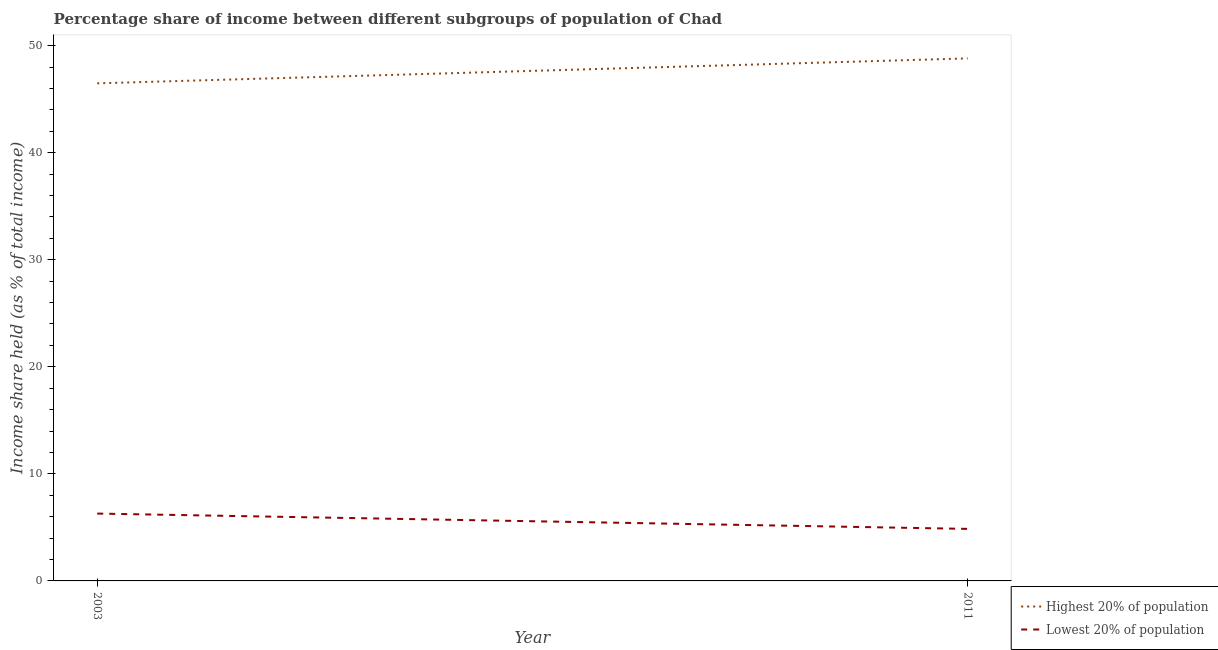What is the income share held by highest 20% of the population in 2003?
Provide a short and direct response. 46.48. Across all years, what is the maximum income share held by lowest 20% of the population?
Offer a very short reply. 6.29. Across all years, what is the minimum income share held by highest 20% of the population?
Your answer should be very brief. 46.48. In which year was the income share held by highest 20% of the population maximum?
Your response must be concise. 2011. In which year was the income share held by highest 20% of the population minimum?
Provide a short and direct response. 2003. What is the total income share held by lowest 20% of the population in the graph?
Provide a short and direct response. 11.15. What is the difference between the income share held by lowest 20% of the population in 2003 and that in 2011?
Provide a short and direct response. 1.43. What is the difference between the income share held by lowest 20% of the population in 2011 and the income share held by highest 20% of the population in 2003?
Offer a terse response. -41.62. What is the average income share held by lowest 20% of the population per year?
Your response must be concise. 5.58. In the year 2011, what is the difference between the income share held by lowest 20% of the population and income share held by highest 20% of the population?
Keep it short and to the point. -43.95. In how many years, is the income share held by lowest 20% of the population greater than 22 %?
Offer a terse response. 0. What is the ratio of the income share held by highest 20% of the population in 2003 to that in 2011?
Provide a short and direct response. 0.95. Is the income share held by lowest 20% of the population in 2003 less than that in 2011?
Provide a short and direct response. No. In how many years, is the income share held by lowest 20% of the population greater than the average income share held by lowest 20% of the population taken over all years?
Offer a terse response. 1. Does the income share held by highest 20% of the population monotonically increase over the years?
Offer a terse response. Yes. How many lines are there?
Ensure brevity in your answer.  2. How many years are there in the graph?
Provide a succinct answer. 2. What is the difference between two consecutive major ticks on the Y-axis?
Ensure brevity in your answer.  10. Where does the legend appear in the graph?
Your answer should be very brief. Bottom right. What is the title of the graph?
Give a very brief answer. Percentage share of income between different subgroups of population of Chad. What is the label or title of the Y-axis?
Provide a succinct answer. Income share held (as % of total income). What is the Income share held (as % of total income) of Highest 20% of population in 2003?
Make the answer very short. 46.48. What is the Income share held (as % of total income) in Lowest 20% of population in 2003?
Ensure brevity in your answer.  6.29. What is the Income share held (as % of total income) in Highest 20% of population in 2011?
Provide a short and direct response. 48.81. What is the Income share held (as % of total income) of Lowest 20% of population in 2011?
Give a very brief answer. 4.86. Across all years, what is the maximum Income share held (as % of total income) of Highest 20% of population?
Your answer should be very brief. 48.81. Across all years, what is the maximum Income share held (as % of total income) of Lowest 20% of population?
Provide a short and direct response. 6.29. Across all years, what is the minimum Income share held (as % of total income) in Highest 20% of population?
Make the answer very short. 46.48. Across all years, what is the minimum Income share held (as % of total income) in Lowest 20% of population?
Make the answer very short. 4.86. What is the total Income share held (as % of total income) of Highest 20% of population in the graph?
Keep it short and to the point. 95.29. What is the total Income share held (as % of total income) of Lowest 20% of population in the graph?
Your response must be concise. 11.15. What is the difference between the Income share held (as % of total income) in Highest 20% of population in 2003 and that in 2011?
Your response must be concise. -2.33. What is the difference between the Income share held (as % of total income) of Lowest 20% of population in 2003 and that in 2011?
Provide a short and direct response. 1.43. What is the difference between the Income share held (as % of total income) of Highest 20% of population in 2003 and the Income share held (as % of total income) of Lowest 20% of population in 2011?
Ensure brevity in your answer.  41.62. What is the average Income share held (as % of total income) in Highest 20% of population per year?
Offer a terse response. 47.65. What is the average Income share held (as % of total income) in Lowest 20% of population per year?
Offer a very short reply. 5.58. In the year 2003, what is the difference between the Income share held (as % of total income) of Highest 20% of population and Income share held (as % of total income) of Lowest 20% of population?
Your answer should be compact. 40.19. In the year 2011, what is the difference between the Income share held (as % of total income) of Highest 20% of population and Income share held (as % of total income) of Lowest 20% of population?
Provide a short and direct response. 43.95. What is the ratio of the Income share held (as % of total income) in Highest 20% of population in 2003 to that in 2011?
Make the answer very short. 0.95. What is the ratio of the Income share held (as % of total income) of Lowest 20% of population in 2003 to that in 2011?
Your answer should be compact. 1.29. What is the difference between the highest and the second highest Income share held (as % of total income) in Highest 20% of population?
Provide a short and direct response. 2.33. What is the difference between the highest and the second highest Income share held (as % of total income) in Lowest 20% of population?
Offer a terse response. 1.43. What is the difference between the highest and the lowest Income share held (as % of total income) in Highest 20% of population?
Your answer should be compact. 2.33. What is the difference between the highest and the lowest Income share held (as % of total income) in Lowest 20% of population?
Offer a very short reply. 1.43. 